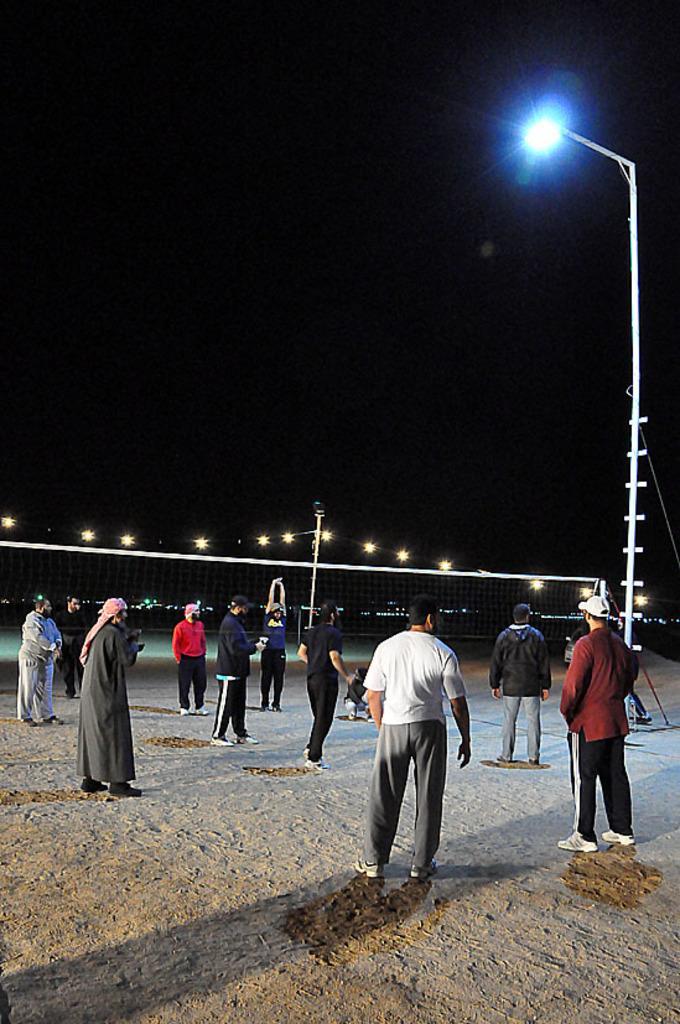Please provide a concise description of this image. In this image we can see these people are standing on the ground, we can see the light pole, net, lights and the dark sky in the background. 